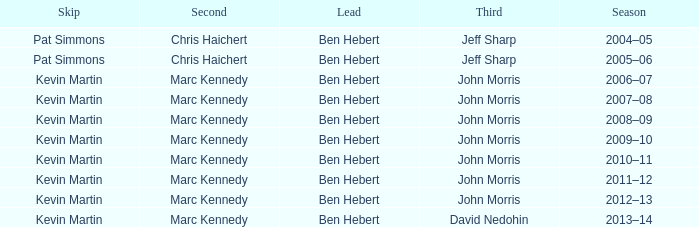What lead has the third David Nedohin? Ben Hebert. 